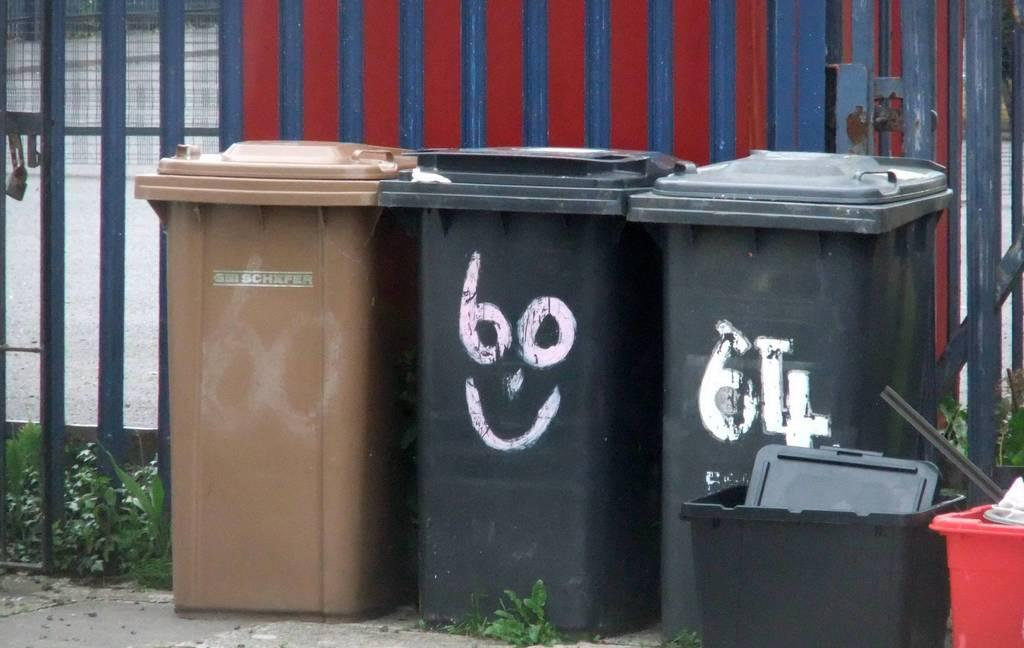<image>
Present a compact description of the photo's key features. Garbage cans next to one another with one saying number 64. 